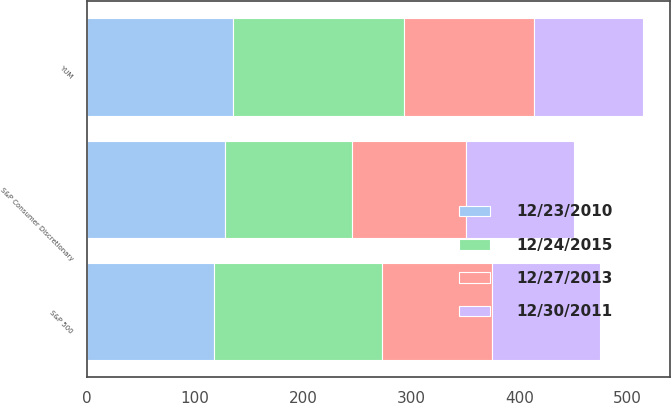Convert chart. <chart><loc_0><loc_0><loc_500><loc_500><stacked_bar_chart><ecel><fcel>YUM<fcel>S&P 500<fcel>S&P Consumer Discretionary<nl><fcel>12/30/2011<fcel>100<fcel>100<fcel>100<nl><fcel>12/27/2013<fcel>121<fcel>102<fcel>106<nl><fcel>12/23/2010<fcel>135<fcel>117<fcel>128<nl><fcel>12/24/2015<fcel>158<fcel>156<fcel>117<nl></chart> 